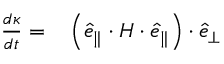Convert formula to latex. <formula><loc_0><loc_0><loc_500><loc_500>\begin{array} { r l } { \frac { d \kappa } { d t } = } & \left ( \hat { e } _ { \| } \cdot H \cdot \hat { e } _ { \| } \right ) \cdot \hat { e } _ { \perp } } \end{array}</formula> 